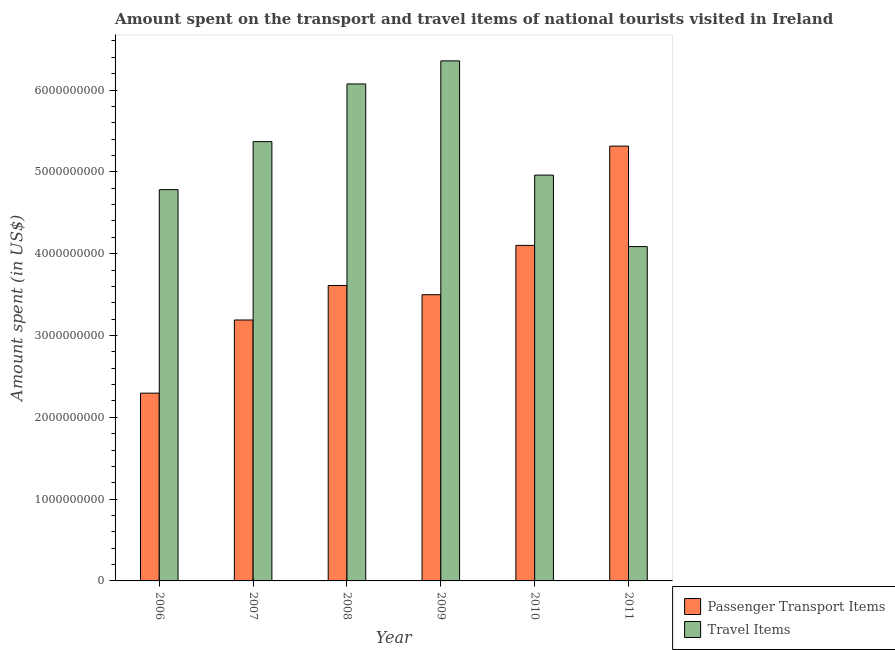How many different coloured bars are there?
Your response must be concise. 2. How many groups of bars are there?
Provide a short and direct response. 6. Are the number of bars per tick equal to the number of legend labels?
Offer a terse response. Yes. Are the number of bars on each tick of the X-axis equal?
Provide a succinct answer. Yes. How many bars are there on the 4th tick from the left?
Your response must be concise. 2. What is the label of the 4th group of bars from the left?
Make the answer very short. 2009. In how many cases, is the number of bars for a given year not equal to the number of legend labels?
Offer a very short reply. 0. What is the amount spent in travel items in 2006?
Provide a succinct answer. 4.78e+09. Across all years, what is the maximum amount spent in travel items?
Make the answer very short. 6.36e+09. Across all years, what is the minimum amount spent in travel items?
Your response must be concise. 4.09e+09. In which year was the amount spent in travel items maximum?
Make the answer very short. 2009. What is the total amount spent in travel items in the graph?
Provide a short and direct response. 3.16e+1. What is the difference between the amount spent on passenger transport items in 2009 and that in 2010?
Provide a succinct answer. -6.03e+08. What is the difference between the amount spent on passenger transport items in 2006 and the amount spent in travel items in 2007?
Your response must be concise. -8.94e+08. What is the average amount spent on passenger transport items per year?
Your answer should be compact. 3.67e+09. In the year 2011, what is the difference between the amount spent in travel items and amount spent on passenger transport items?
Your answer should be very brief. 0. What is the ratio of the amount spent on passenger transport items in 2010 to that in 2011?
Make the answer very short. 0.77. Is the amount spent on passenger transport items in 2009 less than that in 2010?
Your answer should be compact. Yes. What is the difference between the highest and the second highest amount spent in travel items?
Provide a short and direct response. 2.82e+08. What is the difference between the highest and the lowest amount spent on passenger transport items?
Offer a terse response. 3.02e+09. In how many years, is the amount spent on passenger transport items greater than the average amount spent on passenger transport items taken over all years?
Make the answer very short. 2. Is the sum of the amount spent on passenger transport items in 2006 and 2009 greater than the maximum amount spent in travel items across all years?
Offer a terse response. Yes. What does the 2nd bar from the left in 2007 represents?
Your answer should be compact. Travel Items. What does the 1st bar from the right in 2007 represents?
Provide a succinct answer. Travel Items. How many bars are there?
Ensure brevity in your answer.  12. Are the values on the major ticks of Y-axis written in scientific E-notation?
Give a very brief answer. No. Does the graph contain any zero values?
Keep it short and to the point. No. Does the graph contain grids?
Give a very brief answer. No. How are the legend labels stacked?
Ensure brevity in your answer.  Vertical. What is the title of the graph?
Provide a short and direct response. Amount spent on the transport and travel items of national tourists visited in Ireland. Does "Subsidies" appear as one of the legend labels in the graph?
Offer a very short reply. No. What is the label or title of the X-axis?
Your response must be concise. Year. What is the label or title of the Y-axis?
Your answer should be compact. Amount spent (in US$). What is the Amount spent (in US$) in Passenger Transport Items in 2006?
Offer a terse response. 2.30e+09. What is the Amount spent (in US$) in Travel Items in 2006?
Keep it short and to the point. 4.78e+09. What is the Amount spent (in US$) of Passenger Transport Items in 2007?
Provide a succinct answer. 3.19e+09. What is the Amount spent (in US$) in Travel Items in 2007?
Provide a succinct answer. 5.37e+09. What is the Amount spent (in US$) of Passenger Transport Items in 2008?
Your answer should be very brief. 3.61e+09. What is the Amount spent (in US$) of Travel Items in 2008?
Your response must be concise. 6.07e+09. What is the Amount spent (in US$) of Passenger Transport Items in 2009?
Make the answer very short. 3.50e+09. What is the Amount spent (in US$) in Travel Items in 2009?
Ensure brevity in your answer.  6.36e+09. What is the Amount spent (in US$) of Passenger Transport Items in 2010?
Offer a terse response. 4.10e+09. What is the Amount spent (in US$) in Travel Items in 2010?
Give a very brief answer. 4.96e+09. What is the Amount spent (in US$) of Passenger Transport Items in 2011?
Offer a very short reply. 5.31e+09. What is the Amount spent (in US$) of Travel Items in 2011?
Give a very brief answer. 4.09e+09. Across all years, what is the maximum Amount spent (in US$) of Passenger Transport Items?
Provide a short and direct response. 5.31e+09. Across all years, what is the maximum Amount spent (in US$) in Travel Items?
Your answer should be very brief. 6.36e+09. Across all years, what is the minimum Amount spent (in US$) in Passenger Transport Items?
Provide a short and direct response. 2.30e+09. Across all years, what is the minimum Amount spent (in US$) in Travel Items?
Provide a short and direct response. 4.09e+09. What is the total Amount spent (in US$) in Passenger Transport Items in the graph?
Provide a succinct answer. 2.20e+1. What is the total Amount spent (in US$) of Travel Items in the graph?
Offer a terse response. 3.16e+1. What is the difference between the Amount spent (in US$) in Passenger Transport Items in 2006 and that in 2007?
Your answer should be very brief. -8.94e+08. What is the difference between the Amount spent (in US$) of Travel Items in 2006 and that in 2007?
Your response must be concise. -5.87e+08. What is the difference between the Amount spent (in US$) of Passenger Transport Items in 2006 and that in 2008?
Keep it short and to the point. -1.32e+09. What is the difference between the Amount spent (in US$) in Travel Items in 2006 and that in 2008?
Provide a short and direct response. -1.29e+09. What is the difference between the Amount spent (in US$) in Passenger Transport Items in 2006 and that in 2009?
Your answer should be compact. -1.20e+09. What is the difference between the Amount spent (in US$) in Travel Items in 2006 and that in 2009?
Provide a succinct answer. -1.57e+09. What is the difference between the Amount spent (in US$) of Passenger Transport Items in 2006 and that in 2010?
Provide a short and direct response. -1.81e+09. What is the difference between the Amount spent (in US$) in Travel Items in 2006 and that in 2010?
Keep it short and to the point. -1.78e+08. What is the difference between the Amount spent (in US$) in Passenger Transport Items in 2006 and that in 2011?
Offer a very short reply. -3.02e+09. What is the difference between the Amount spent (in US$) in Travel Items in 2006 and that in 2011?
Give a very brief answer. 6.96e+08. What is the difference between the Amount spent (in US$) of Passenger Transport Items in 2007 and that in 2008?
Give a very brief answer. -4.22e+08. What is the difference between the Amount spent (in US$) in Travel Items in 2007 and that in 2008?
Your answer should be very brief. -7.05e+08. What is the difference between the Amount spent (in US$) of Passenger Transport Items in 2007 and that in 2009?
Give a very brief answer. -3.09e+08. What is the difference between the Amount spent (in US$) in Travel Items in 2007 and that in 2009?
Offer a terse response. -9.87e+08. What is the difference between the Amount spent (in US$) in Passenger Transport Items in 2007 and that in 2010?
Your answer should be compact. -9.12e+08. What is the difference between the Amount spent (in US$) of Travel Items in 2007 and that in 2010?
Give a very brief answer. 4.09e+08. What is the difference between the Amount spent (in US$) of Passenger Transport Items in 2007 and that in 2011?
Make the answer very short. -2.12e+09. What is the difference between the Amount spent (in US$) of Travel Items in 2007 and that in 2011?
Offer a terse response. 1.28e+09. What is the difference between the Amount spent (in US$) in Passenger Transport Items in 2008 and that in 2009?
Ensure brevity in your answer.  1.13e+08. What is the difference between the Amount spent (in US$) of Travel Items in 2008 and that in 2009?
Your answer should be very brief. -2.82e+08. What is the difference between the Amount spent (in US$) in Passenger Transport Items in 2008 and that in 2010?
Give a very brief answer. -4.90e+08. What is the difference between the Amount spent (in US$) of Travel Items in 2008 and that in 2010?
Give a very brief answer. 1.11e+09. What is the difference between the Amount spent (in US$) in Passenger Transport Items in 2008 and that in 2011?
Provide a succinct answer. -1.70e+09. What is the difference between the Amount spent (in US$) of Travel Items in 2008 and that in 2011?
Offer a very short reply. 1.99e+09. What is the difference between the Amount spent (in US$) in Passenger Transport Items in 2009 and that in 2010?
Your response must be concise. -6.03e+08. What is the difference between the Amount spent (in US$) in Travel Items in 2009 and that in 2010?
Offer a terse response. 1.40e+09. What is the difference between the Amount spent (in US$) of Passenger Transport Items in 2009 and that in 2011?
Offer a very short reply. -1.82e+09. What is the difference between the Amount spent (in US$) in Travel Items in 2009 and that in 2011?
Offer a very short reply. 2.27e+09. What is the difference between the Amount spent (in US$) of Passenger Transport Items in 2010 and that in 2011?
Provide a short and direct response. -1.21e+09. What is the difference between the Amount spent (in US$) of Travel Items in 2010 and that in 2011?
Offer a terse response. 8.74e+08. What is the difference between the Amount spent (in US$) of Passenger Transport Items in 2006 and the Amount spent (in US$) of Travel Items in 2007?
Your answer should be very brief. -3.07e+09. What is the difference between the Amount spent (in US$) in Passenger Transport Items in 2006 and the Amount spent (in US$) in Travel Items in 2008?
Give a very brief answer. -3.78e+09. What is the difference between the Amount spent (in US$) in Passenger Transport Items in 2006 and the Amount spent (in US$) in Travel Items in 2009?
Your response must be concise. -4.06e+09. What is the difference between the Amount spent (in US$) in Passenger Transport Items in 2006 and the Amount spent (in US$) in Travel Items in 2010?
Offer a very short reply. -2.66e+09. What is the difference between the Amount spent (in US$) in Passenger Transport Items in 2006 and the Amount spent (in US$) in Travel Items in 2011?
Your answer should be very brief. -1.79e+09. What is the difference between the Amount spent (in US$) in Passenger Transport Items in 2007 and the Amount spent (in US$) in Travel Items in 2008?
Offer a very short reply. -2.88e+09. What is the difference between the Amount spent (in US$) of Passenger Transport Items in 2007 and the Amount spent (in US$) of Travel Items in 2009?
Make the answer very short. -3.17e+09. What is the difference between the Amount spent (in US$) in Passenger Transport Items in 2007 and the Amount spent (in US$) in Travel Items in 2010?
Offer a very short reply. -1.77e+09. What is the difference between the Amount spent (in US$) of Passenger Transport Items in 2007 and the Amount spent (in US$) of Travel Items in 2011?
Keep it short and to the point. -8.97e+08. What is the difference between the Amount spent (in US$) of Passenger Transport Items in 2008 and the Amount spent (in US$) of Travel Items in 2009?
Give a very brief answer. -2.74e+09. What is the difference between the Amount spent (in US$) in Passenger Transport Items in 2008 and the Amount spent (in US$) in Travel Items in 2010?
Your answer should be compact. -1.35e+09. What is the difference between the Amount spent (in US$) of Passenger Transport Items in 2008 and the Amount spent (in US$) of Travel Items in 2011?
Ensure brevity in your answer.  -4.75e+08. What is the difference between the Amount spent (in US$) of Passenger Transport Items in 2009 and the Amount spent (in US$) of Travel Items in 2010?
Give a very brief answer. -1.46e+09. What is the difference between the Amount spent (in US$) in Passenger Transport Items in 2009 and the Amount spent (in US$) in Travel Items in 2011?
Ensure brevity in your answer.  -5.88e+08. What is the difference between the Amount spent (in US$) of Passenger Transport Items in 2010 and the Amount spent (in US$) of Travel Items in 2011?
Offer a terse response. 1.50e+07. What is the average Amount spent (in US$) of Passenger Transport Items per year?
Offer a very short reply. 3.67e+09. What is the average Amount spent (in US$) of Travel Items per year?
Make the answer very short. 5.27e+09. In the year 2006, what is the difference between the Amount spent (in US$) of Passenger Transport Items and Amount spent (in US$) of Travel Items?
Ensure brevity in your answer.  -2.49e+09. In the year 2007, what is the difference between the Amount spent (in US$) in Passenger Transport Items and Amount spent (in US$) in Travel Items?
Provide a short and direct response. -2.18e+09. In the year 2008, what is the difference between the Amount spent (in US$) in Passenger Transport Items and Amount spent (in US$) in Travel Items?
Provide a short and direct response. -2.46e+09. In the year 2009, what is the difference between the Amount spent (in US$) in Passenger Transport Items and Amount spent (in US$) in Travel Items?
Provide a succinct answer. -2.86e+09. In the year 2010, what is the difference between the Amount spent (in US$) in Passenger Transport Items and Amount spent (in US$) in Travel Items?
Offer a terse response. -8.59e+08. In the year 2011, what is the difference between the Amount spent (in US$) in Passenger Transport Items and Amount spent (in US$) in Travel Items?
Your response must be concise. 1.23e+09. What is the ratio of the Amount spent (in US$) in Passenger Transport Items in 2006 to that in 2007?
Keep it short and to the point. 0.72. What is the ratio of the Amount spent (in US$) of Travel Items in 2006 to that in 2007?
Keep it short and to the point. 0.89. What is the ratio of the Amount spent (in US$) of Passenger Transport Items in 2006 to that in 2008?
Give a very brief answer. 0.64. What is the ratio of the Amount spent (in US$) in Travel Items in 2006 to that in 2008?
Ensure brevity in your answer.  0.79. What is the ratio of the Amount spent (in US$) in Passenger Transport Items in 2006 to that in 2009?
Offer a very short reply. 0.66. What is the ratio of the Amount spent (in US$) in Travel Items in 2006 to that in 2009?
Your answer should be compact. 0.75. What is the ratio of the Amount spent (in US$) of Passenger Transport Items in 2006 to that in 2010?
Your answer should be very brief. 0.56. What is the ratio of the Amount spent (in US$) in Travel Items in 2006 to that in 2010?
Offer a very short reply. 0.96. What is the ratio of the Amount spent (in US$) of Passenger Transport Items in 2006 to that in 2011?
Your response must be concise. 0.43. What is the ratio of the Amount spent (in US$) of Travel Items in 2006 to that in 2011?
Provide a short and direct response. 1.17. What is the ratio of the Amount spent (in US$) of Passenger Transport Items in 2007 to that in 2008?
Your response must be concise. 0.88. What is the ratio of the Amount spent (in US$) in Travel Items in 2007 to that in 2008?
Your answer should be very brief. 0.88. What is the ratio of the Amount spent (in US$) in Passenger Transport Items in 2007 to that in 2009?
Give a very brief answer. 0.91. What is the ratio of the Amount spent (in US$) of Travel Items in 2007 to that in 2009?
Ensure brevity in your answer.  0.84. What is the ratio of the Amount spent (in US$) of Passenger Transport Items in 2007 to that in 2010?
Ensure brevity in your answer.  0.78. What is the ratio of the Amount spent (in US$) of Travel Items in 2007 to that in 2010?
Your answer should be very brief. 1.08. What is the ratio of the Amount spent (in US$) in Passenger Transport Items in 2007 to that in 2011?
Offer a terse response. 0.6. What is the ratio of the Amount spent (in US$) of Travel Items in 2007 to that in 2011?
Your response must be concise. 1.31. What is the ratio of the Amount spent (in US$) of Passenger Transport Items in 2008 to that in 2009?
Your answer should be compact. 1.03. What is the ratio of the Amount spent (in US$) of Travel Items in 2008 to that in 2009?
Ensure brevity in your answer.  0.96. What is the ratio of the Amount spent (in US$) of Passenger Transport Items in 2008 to that in 2010?
Your response must be concise. 0.88. What is the ratio of the Amount spent (in US$) in Travel Items in 2008 to that in 2010?
Provide a succinct answer. 1.22. What is the ratio of the Amount spent (in US$) in Passenger Transport Items in 2008 to that in 2011?
Offer a terse response. 0.68. What is the ratio of the Amount spent (in US$) of Travel Items in 2008 to that in 2011?
Your answer should be compact. 1.49. What is the ratio of the Amount spent (in US$) in Passenger Transport Items in 2009 to that in 2010?
Ensure brevity in your answer.  0.85. What is the ratio of the Amount spent (in US$) of Travel Items in 2009 to that in 2010?
Offer a very short reply. 1.28. What is the ratio of the Amount spent (in US$) in Passenger Transport Items in 2009 to that in 2011?
Your answer should be very brief. 0.66. What is the ratio of the Amount spent (in US$) in Travel Items in 2009 to that in 2011?
Your response must be concise. 1.56. What is the ratio of the Amount spent (in US$) of Passenger Transport Items in 2010 to that in 2011?
Make the answer very short. 0.77. What is the ratio of the Amount spent (in US$) in Travel Items in 2010 to that in 2011?
Your answer should be compact. 1.21. What is the difference between the highest and the second highest Amount spent (in US$) of Passenger Transport Items?
Your response must be concise. 1.21e+09. What is the difference between the highest and the second highest Amount spent (in US$) in Travel Items?
Ensure brevity in your answer.  2.82e+08. What is the difference between the highest and the lowest Amount spent (in US$) of Passenger Transport Items?
Your response must be concise. 3.02e+09. What is the difference between the highest and the lowest Amount spent (in US$) of Travel Items?
Your answer should be compact. 2.27e+09. 